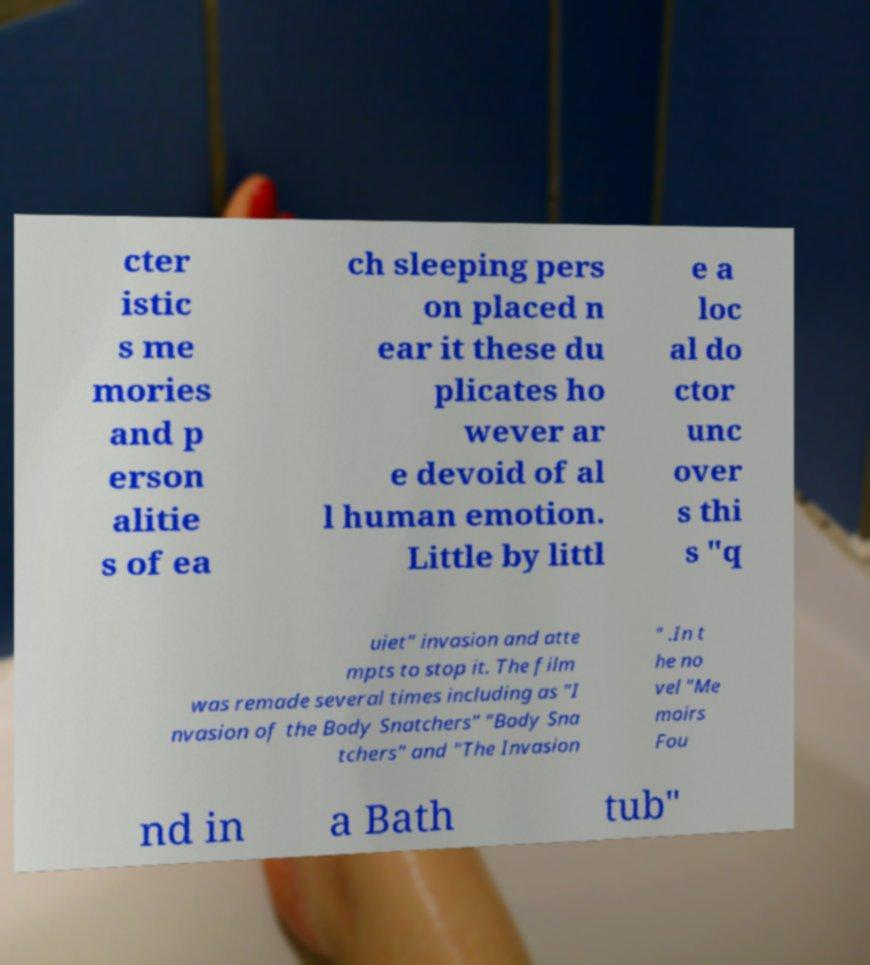Please read and relay the text visible in this image. What does it say? cter istic s me mories and p erson alitie s of ea ch sleeping pers on placed n ear it these du plicates ho wever ar e devoid of al l human emotion. Little by littl e a loc al do ctor unc over s thi s "q uiet" invasion and atte mpts to stop it. The film was remade several times including as "I nvasion of the Body Snatchers" "Body Sna tchers" and "The Invasion " .In t he no vel "Me moirs Fou nd in a Bath tub" 